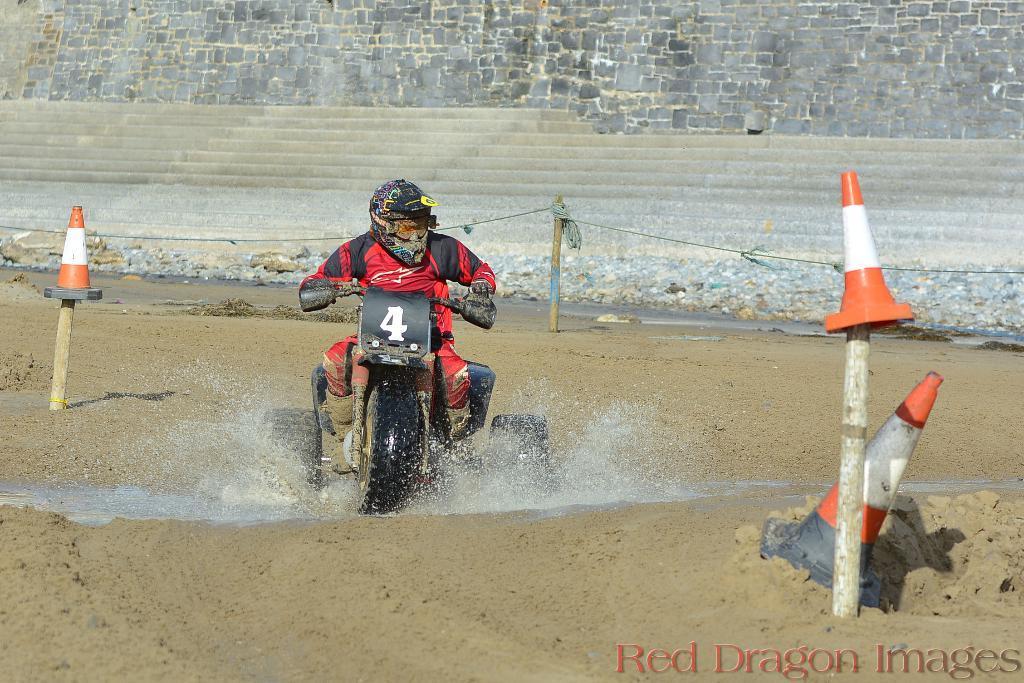How would you summarize this image in a sentence or two? In the center of the image we can see a person wearing a helmet is riding a bike in water. To the left and right side of the image we can see the cones on wooden poles and a cone placed on the ground. In the background, we can see a pole with ropes, some rocks on ground and the wall. At the bottom right corner of the image we can see some text. 